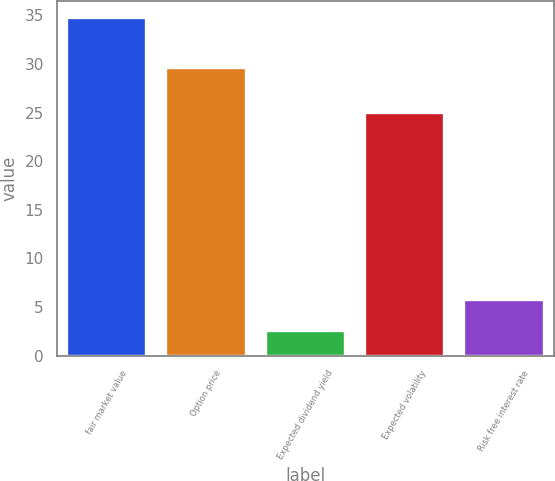Convert chart to OTSL. <chart><loc_0><loc_0><loc_500><loc_500><bar_chart><fcel>fair market value<fcel>Option price<fcel>Expected dividend yield<fcel>Expected volatility<fcel>Risk free interest rate<nl><fcel>34.79<fcel>29.57<fcel>2.56<fcel>25<fcel>5.78<nl></chart> 